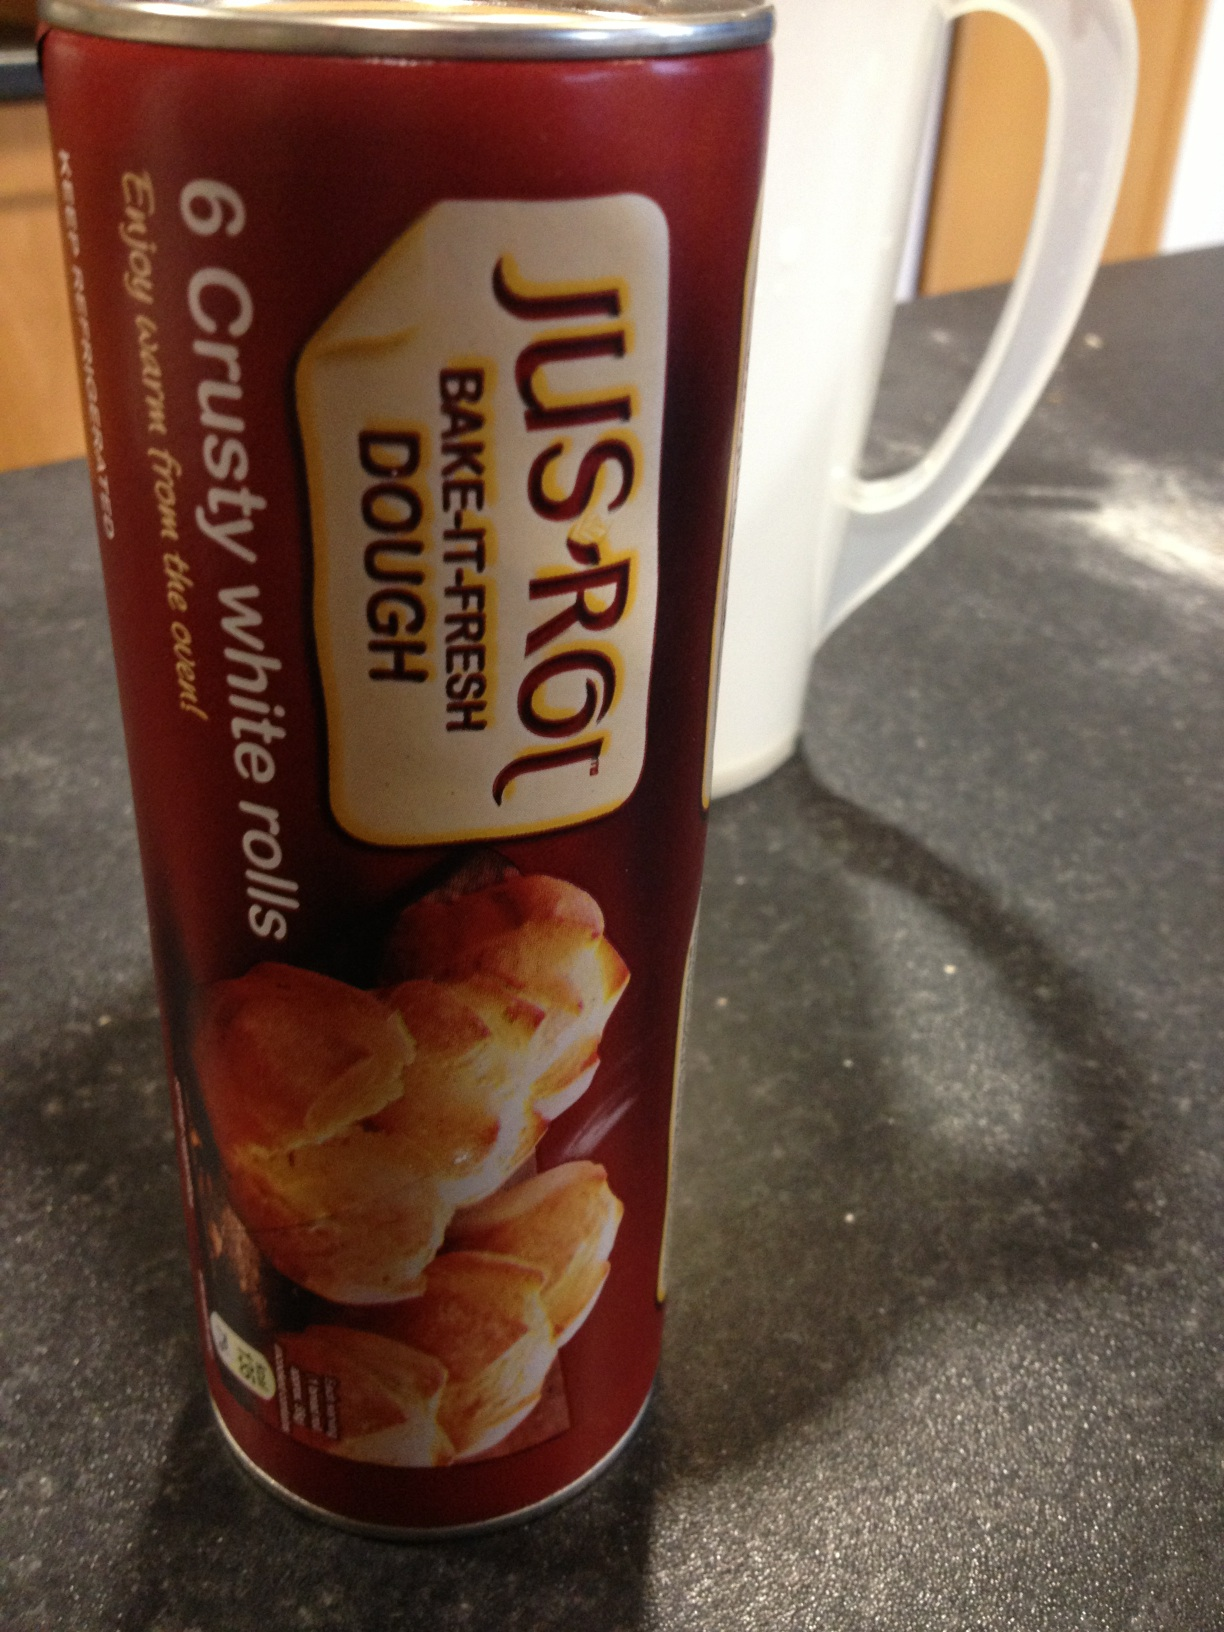Please can you tell me what this product is? This product is 'Jus-Rol Bake-It-Fresh Dough' for making 6 crusty white rolls. It is a ready-to-bake dough that allows you to enjoy fresh, warm rolls right from your oven. Simply follow the baking instructions on the package for delicious homemade rolls. 